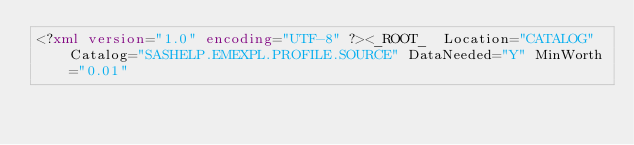<code> <loc_0><loc_0><loc_500><loc_500><_XML_><?xml version="1.0" encoding="UTF-8" ?><_ROOT_  Location="CATALOG" Catalog="SASHELP.EMEXPL.PROFILE.SOURCE" DataNeeded="Y" MinWorth="0.01"</code> 